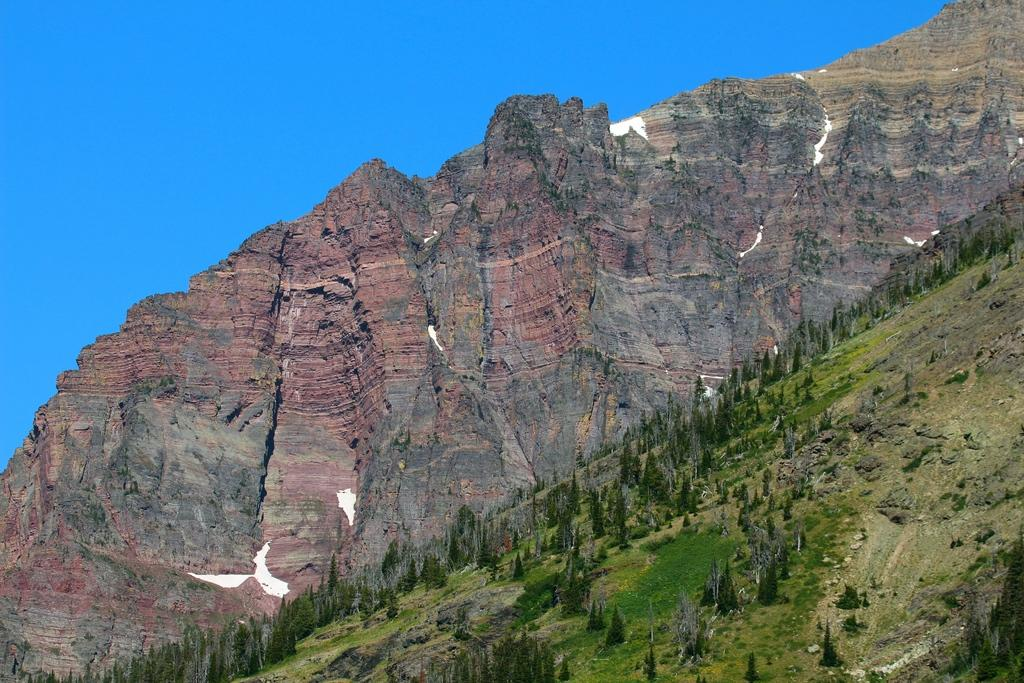What type of natural features can be seen in the image? There are trees and mountains in the image. What is visible at the top of the image? The sky is visible at the top of the image. How many clocks can be seen hanging from the trees in the image? There are no clocks visible in the image; it features trees, mountains, and the sky. What type of cheese is present on the mountain in the image? There is no cheese present in the image; it only features trees, mountains, and the sky. 